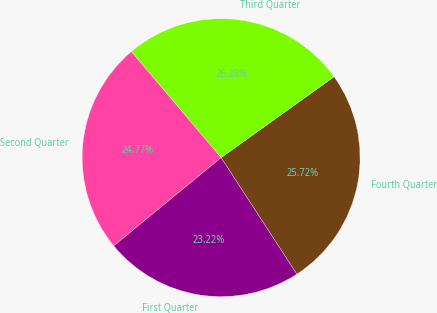Convert chart to OTSL. <chart><loc_0><loc_0><loc_500><loc_500><pie_chart><fcel>Fourth Quarter<fcel>Third Quarter<fcel>Second Quarter<fcel>First Quarter<nl><fcel>25.72%<fcel>26.28%<fcel>24.77%<fcel>23.22%<nl></chart> 